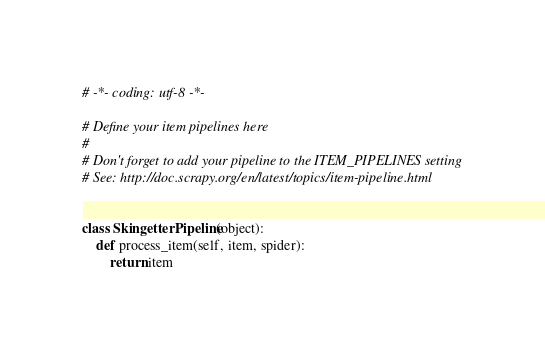<code> <loc_0><loc_0><loc_500><loc_500><_Python_># -*- coding: utf-8 -*-

# Define your item pipelines here
#
# Don't forget to add your pipeline to the ITEM_PIPELINES setting
# See: http://doc.scrapy.org/en/latest/topics/item-pipeline.html


class SkingetterPipeline(object):
    def process_item(self, item, spider):
        return item
</code> 